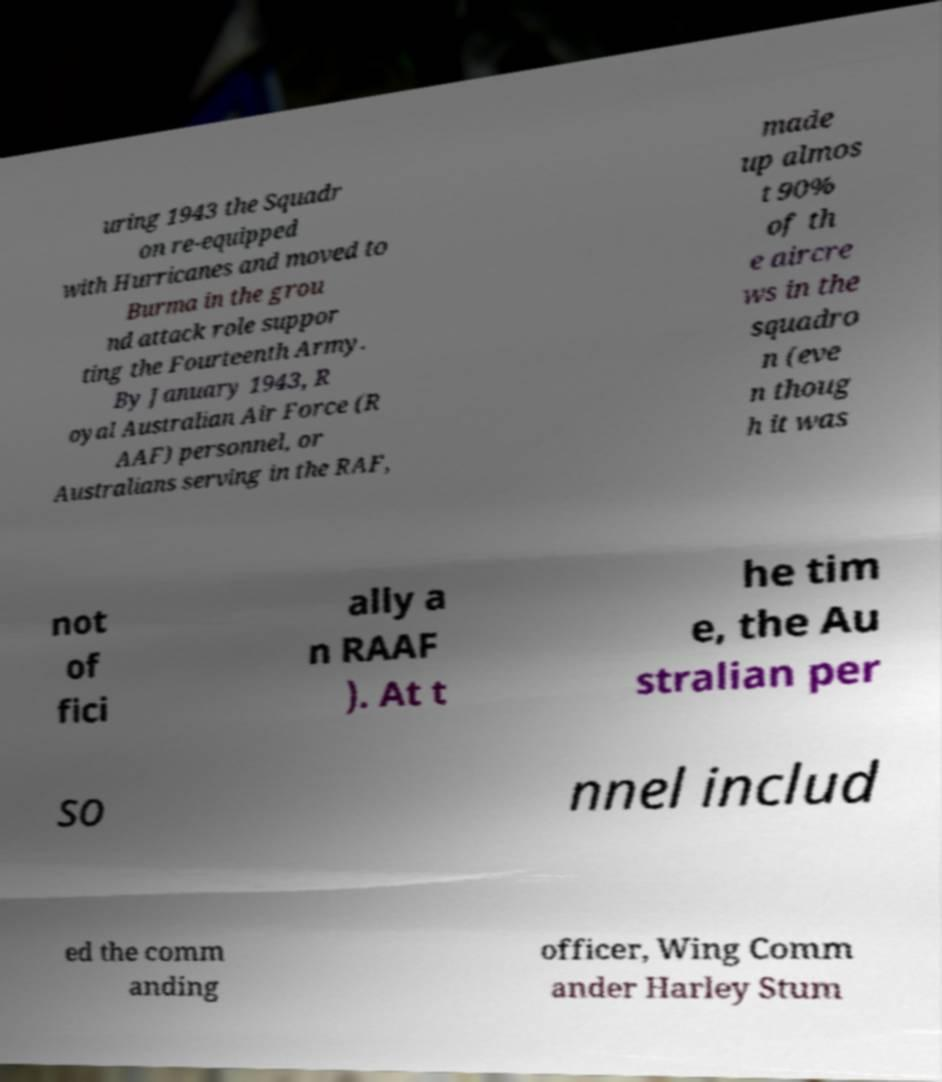Can you accurately transcribe the text from the provided image for me? uring 1943 the Squadr on re-equipped with Hurricanes and moved to Burma in the grou nd attack role suppor ting the Fourteenth Army. By January 1943, R oyal Australian Air Force (R AAF) personnel, or Australians serving in the RAF, made up almos t 90% of th e aircre ws in the squadro n (eve n thoug h it was not of fici ally a n RAAF ). At t he tim e, the Au stralian per so nnel includ ed the comm anding officer, Wing Comm ander Harley Stum 